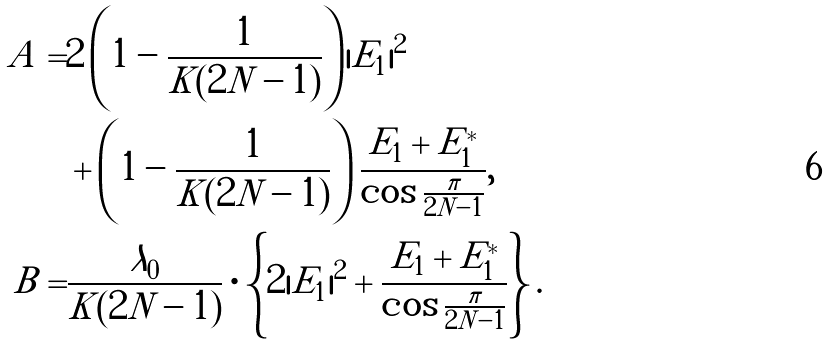<formula> <loc_0><loc_0><loc_500><loc_500>A = & 2 \left ( 1 - \frac { 1 } { K ( 2 N - 1 ) } \right ) | E _ { 1 } | ^ { 2 } \\ & + \left ( 1 - \frac { 1 } { K ( 2 N - 1 ) } \right ) \frac { E _ { 1 } + E ^ { * } _ { 1 } } { \cos \frac { \pi } { 2 N - 1 } } , \\ B = & \frac { \lambda _ { 0 } } { K ( 2 N - 1 ) } \cdot \left \{ 2 | E _ { 1 } | ^ { 2 } + \frac { E _ { 1 } + E ^ { * } _ { 1 } } { \cos \frac { \pi } { 2 N - 1 } } \right \} .</formula> 